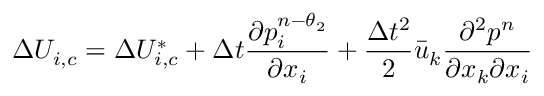<formula> <loc_0><loc_0><loc_500><loc_500>\Delta { { U } _ { i , c } } = \Delta U _ { i , c } ^ { * } + \Delta t \frac { \partial p _ { i } ^ { n - { { \theta } _ { 2 } } } } { \partial { { x } _ { i } } } + \frac { \Delta { { t } ^ { 2 } } } { 2 } { { \bar { u } } _ { k } } \frac { { { \partial } ^ { 2 } } { { p } ^ { n } } } { \partial { { x } _ { k } } \partial { { x } _ { i } } }</formula> 